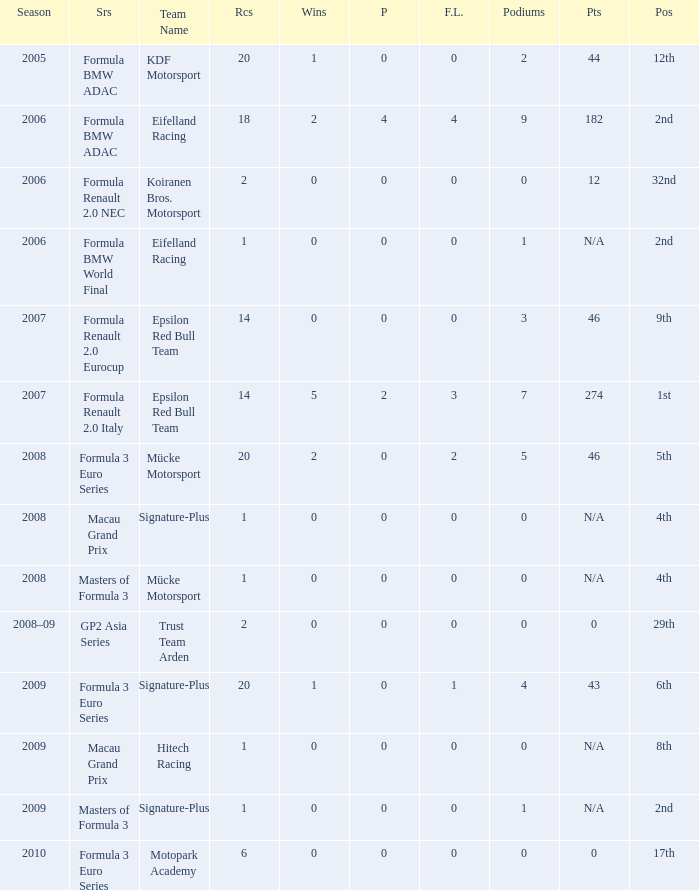What is the average number of podiums in the 32nd position with less than 0 wins? None. Would you mind parsing the complete table? {'header': ['Season', 'Srs', 'Team Name', 'Rcs', 'Wins', 'P', 'F.L.', 'Podiums', 'Pts', 'Pos'], 'rows': [['2005', 'Formula BMW ADAC', 'KDF Motorsport', '20', '1', '0', '0', '2', '44', '12th'], ['2006', 'Formula BMW ADAC', 'Eifelland Racing', '18', '2', '4', '4', '9', '182', '2nd'], ['2006', 'Formula Renault 2.0 NEC', 'Koiranen Bros. Motorsport', '2', '0', '0', '0', '0', '12', '32nd'], ['2006', 'Formula BMW World Final', 'Eifelland Racing', '1', '0', '0', '0', '1', 'N/A', '2nd'], ['2007', 'Formula Renault 2.0 Eurocup', 'Epsilon Red Bull Team', '14', '0', '0', '0', '3', '46', '9th'], ['2007', 'Formula Renault 2.0 Italy', 'Epsilon Red Bull Team', '14', '5', '2', '3', '7', '274', '1st'], ['2008', 'Formula 3 Euro Series', 'Mücke Motorsport', '20', '2', '0', '2', '5', '46', '5th'], ['2008', 'Macau Grand Prix', 'Signature-Plus', '1', '0', '0', '0', '0', 'N/A', '4th'], ['2008', 'Masters of Formula 3', 'Mücke Motorsport', '1', '0', '0', '0', '0', 'N/A', '4th'], ['2008–09', 'GP2 Asia Series', 'Trust Team Arden', '2', '0', '0', '0', '0', '0', '29th'], ['2009', 'Formula 3 Euro Series', 'Signature-Plus', '20', '1', '0', '1', '4', '43', '6th'], ['2009', 'Macau Grand Prix', 'Hitech Racing', '1', '0', '0', '0', '0', 'N/A', '8th'], ['2009', 'Masters of Formula 3', 'Signature-Plus', '1', '0', '0', '0', '1', 'N/A', '2nd'], ['2010', 'Formula 3 Euro Series', 'Motopark Academy', '6', '0', '0', '0', '0', '0', '17th']]} 